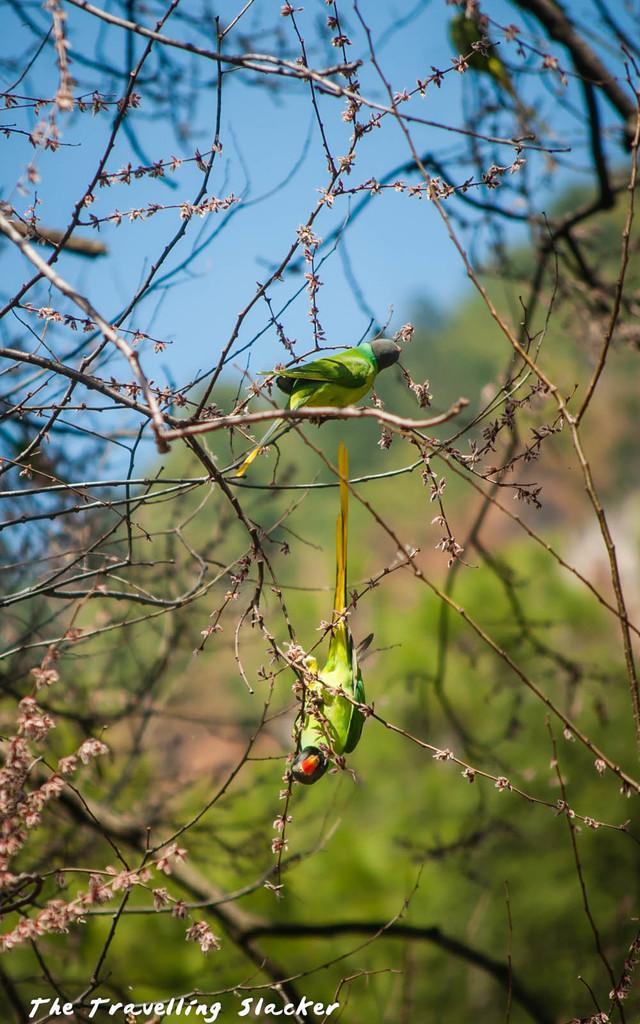Could you give a brief overview of what you see in this image? In this image there are two parrots on the branch of a tree. In the background of the image there are trees and sky. 